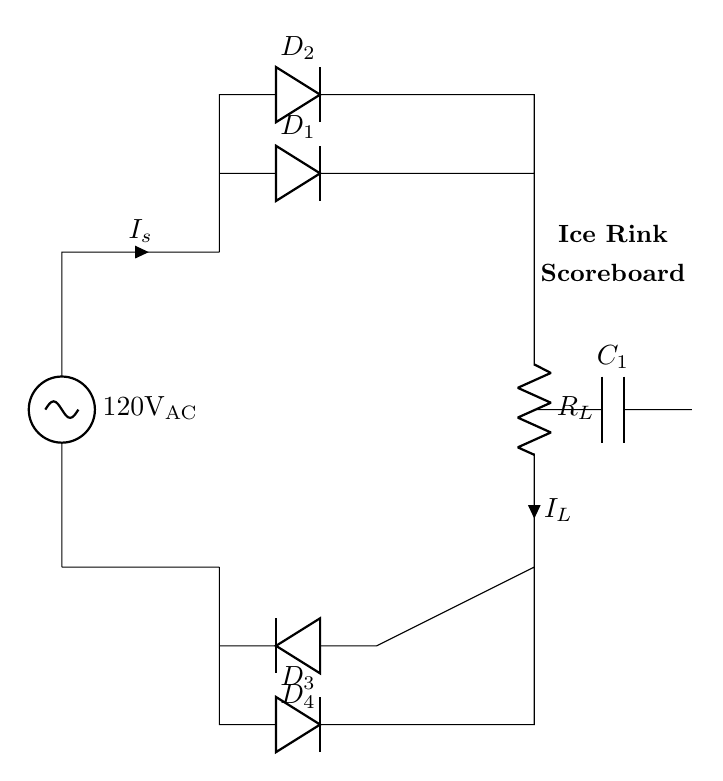What is the AC voltage supplied to the circuit? The circuit shows a supply voltage labeled as 120V AC, indicating the input voltage level supplied to the full-wave bridge rectifier.
Answer: 120V AC What components are used in this rectifier circuit? The circuit diagram includes the following components: four diodes (D1, D2, D3, D4), a capacitor (C1), and a load resistor (R_L). The diodes are configured in a bridge layout to convert AC to DC.
Answer: Diodes, capacitor, resistor What is the purpose of the capacitor in this circuit? The capacitor (C1) is used to smooth the output voltage after rectification. It charges during the peaks of the rectified voltage, reducing voltage fluctuations across the load resistor (R_L).
Answer: Smoothing output voltage How many diodes are utilized in this bridge rectifier? The bridge rectifier circuit features four diodes, which work together to allow current to flow in both halves of the AC input cycle, effectively rectifying the voltage to DC.
Answer: Four diodes What is the direction of current flow through D1 during positive half-cycles? During the positive half-cycle of the AC input, the current flows from the source through D1 to the load resistor (R_L), confirming that D1 is forward-biased and conducting.
Answer: Forward-biased Explain how the full-wave rectification is achieved in this circuit. Full-wave rectification is accomplished using four diodes arranged in a bridge configuration. As the AC input alternates, diodes conduct in pairs; during the positive half-cycle, D1 and D2 conduct, allowing current to flow to the load. In the negative half-cycle, D3 and D4 conduct, maintaining current direction through the load. This results in a continuous flow of current in a single direction, effectively converting AC to DC.
Answer: Bridge configuration of diodes 